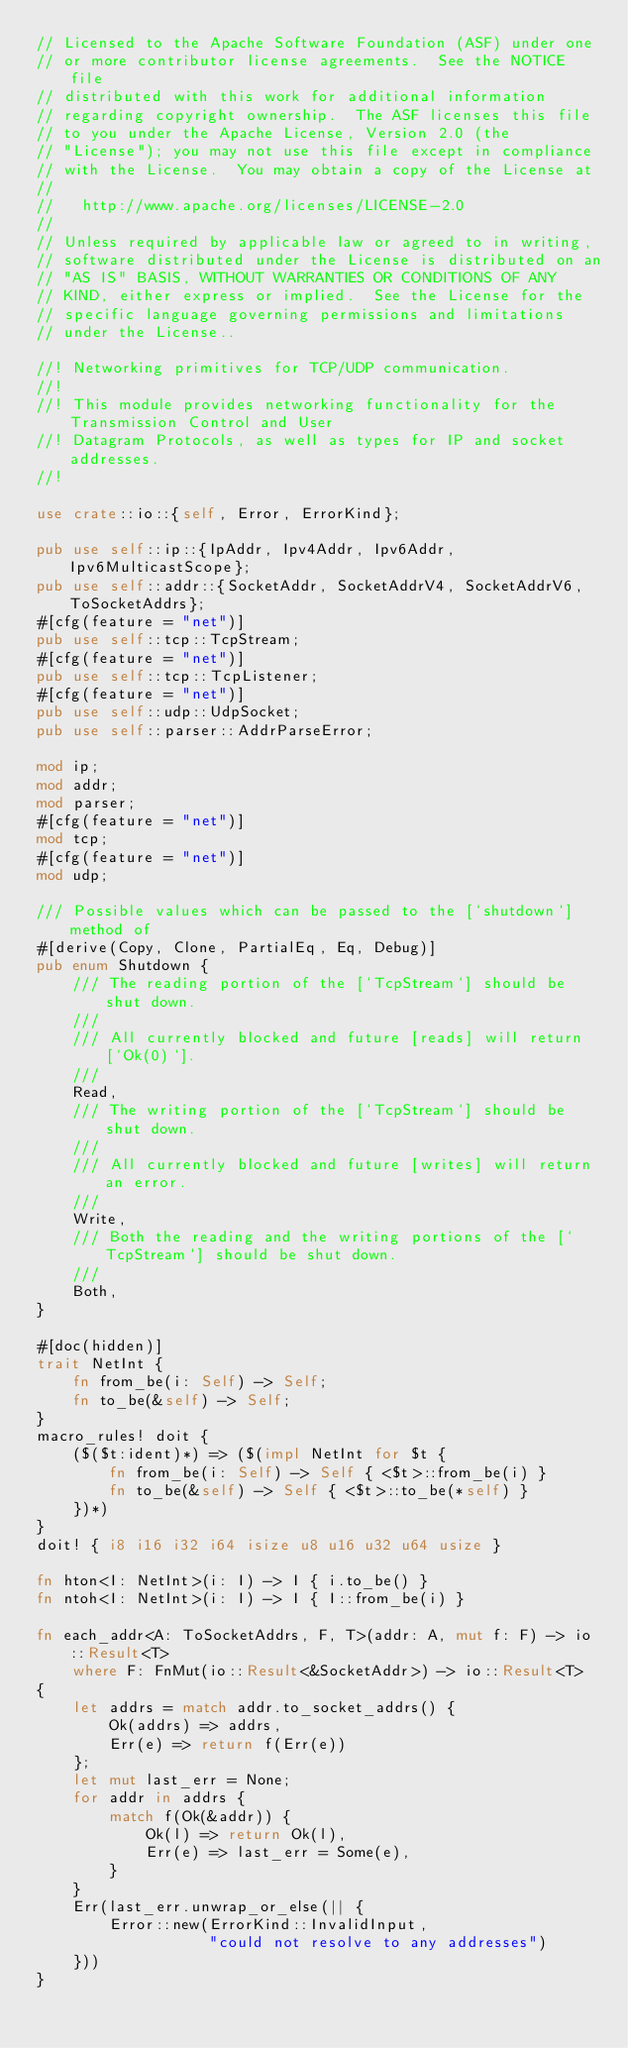<code> <loc_0><loc_0><loc_500><loc_500><_Rust_>// Licensed to the Apache Software Foundation (ASF) under one
// or more contributor license agreements.  See the NOTICE file
// distributed with this work for additional information
// regarding copyright ownership.  The ASF licenses this file
// to you under the Apache License, Version 2.0 (the
// "License"); you may not use this file except in compliance
// with the License.  You may obtain a copy of the License at
//
//   http://www.apache.org/licenses/LICENSE-2.0
//
// Unless required by applicable law or agreed to in writing,
// software distributed under the License is distributed on an
// "AS IS" BASIS, WITHOUT WARRANTIES OR CONDITIONS OF ANY
// KIND, either express or implied.  See the License for the
// specific language governing permissions and limitations
// under the License..

//! Networking primitives for TCP/UDP communication.
//!
//! This module provides networking functionality for the Transmission Control and User
//! Datagram Protocols, as well as types for IP and socket addresses.
//!

use crate::io::{self, Error, ErrorKind};

pub use self::ip::{IpAddr, Ipv4Addr, Ipv6Addr, Ipv6MulticastScope};
pub use self::addr::{SocketAddr, SocketAddrV4, SocketAddrV6, ToSocketAddrs};
#[cfg(feature = "net")]
pub use self::tcp::TcpStream;
#[cfg(feature = "net")]
pub use self::tcp::TcpListener;
#[cfg(feature = "net")]
pub use self::udp::UdpSocket;
pub use self::parser::AddrParseError;

mod ip;
mod addr;
mod parser;
#[cfg(feature = "net")]
mod tcp;
#[cfg(feature = "net")]
mod udp;

/// Possible values which can be passed to the [`shutdown`] method of
#[derive(Copy, Clone, PartialEq, Eq, Debug)]
pub enum Shutdown {
    /// The reading portion of the [`TcpStream`] should be shut down.
    ///
    /// All currently blocked and future [reads] will return [`Ok(0)`].
    ///
    Read,
    /// The writing portion of the [`TcpStream`] should be shut down.
    ///
    /// All currently blocked and future [writes] will return an error.
    ///
    Write,
    /// Both the reading and the writing portions of the [`TcpStream`] should be shut down.
    ///
    Both,
}

#[doc(hidden)]
trait NetInt {
    fn from_be(i: Self) -> Self;
    fn to_be(&self) -> Self;
}
macro_rules! doit {
    ($($t:ident)*) => ($(impl NetInt for $t {
        fn from_be(i: Self) -> Self { <$t>::from_be(i) }
        fn to_be(&self) -> Self { <$t>::to_be(*self) }
    })*)
}
doit! { i8 i16 i32 i64 isize u8 u16 u32 u64 usize }

fn hton<I: NetInt>(i: I) -> I { i.to_be() }
fn ntoh<I: NetInt>(i: I) -> I { I::from_be(i) }

fn each_addr<A: ToSocketAddrs, F, T>(addr: A, mut f: F) -> io::Result<T>
    where F: FnMut(io::Result<&SocketAddr>) -> io::Result<T>
{
    let addrs = match addr.to_socket_addrs() {
        Ok(addrs) => addrs,
        Err(e) => return f(Err(e))
    };
    let mut last_err = None;
    for addr in addrs {
        match f(Ok(&addr)) {
            Ok(l) => return Ok(l),
            Err(e) => last_err = Some(e),
        }
    }
    Err(last_err.unwrap_or_else(|| {
        Error::new(ErrorKind::InvalidInput,
                   "could not resolve to any addresses")
    }))
}</code> 